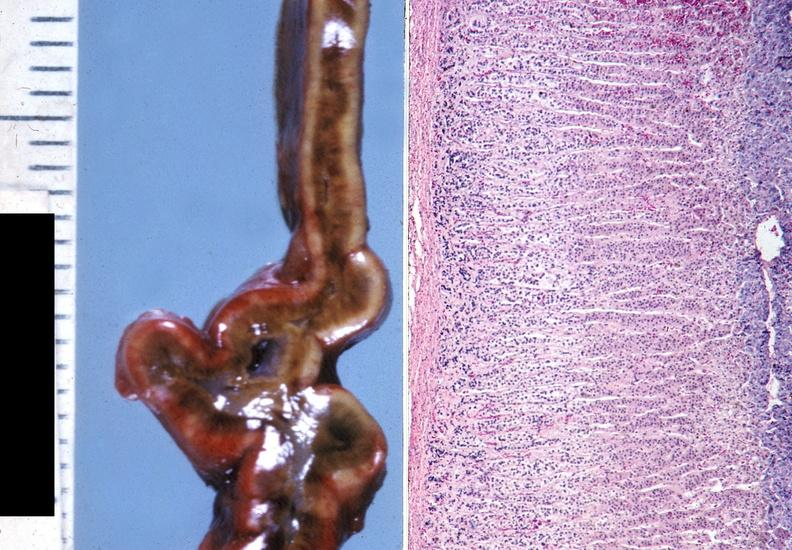does capillary show adrenal, cushing syndrome?
Answer the question using a single word or phrase. No 